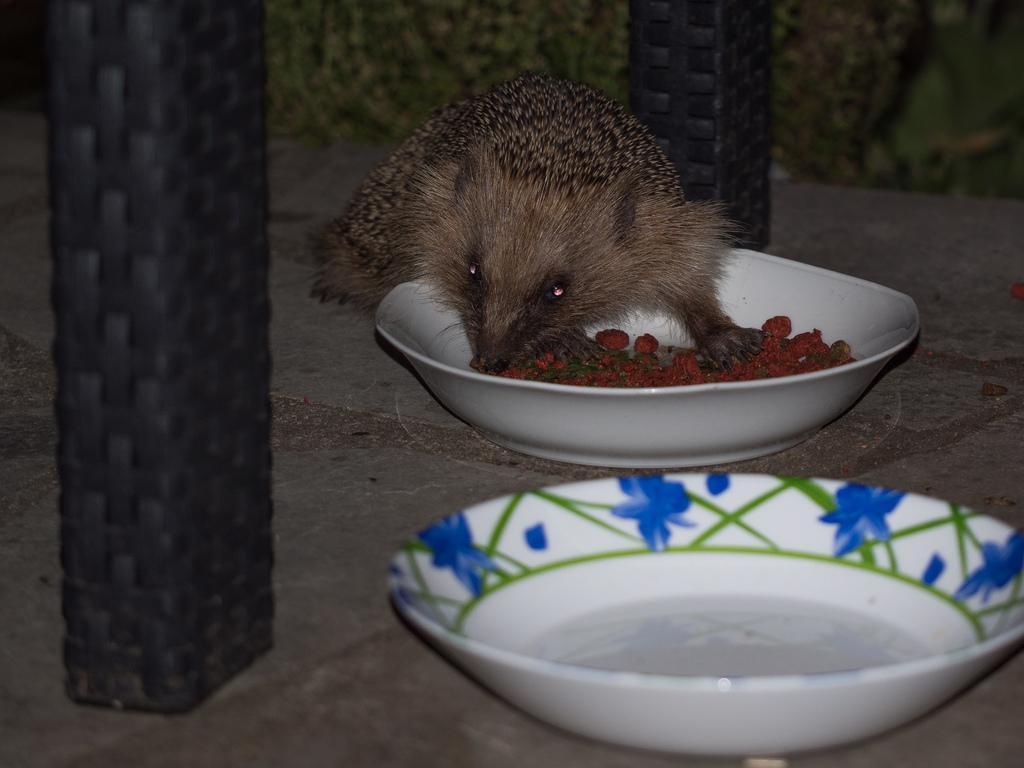Please provide a concise description of this image. Background portion of the picture is blur. In this picture we can see a rat eating food. We can see food in the bowl. We can see liquid in the other bowl. We can see the floor and objects. 